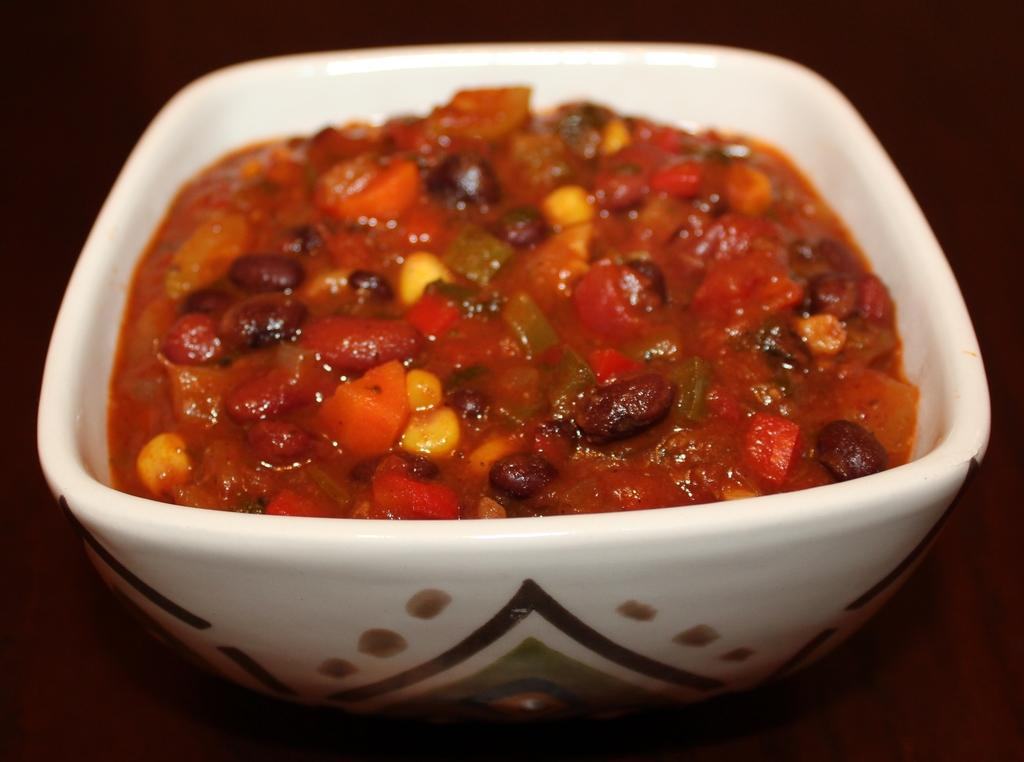What color is the bowl in the image? The bowl in the image is white. What is the bowl placed on? The bowl is placed on an object. What is inside the bowl? There is a food item in the bowl. Can you see any waves in the image? There are no waves present in the image. What type of comb is being used to prepare the food in the image? There is no comb visible in the image, and no food preparation is shown. 